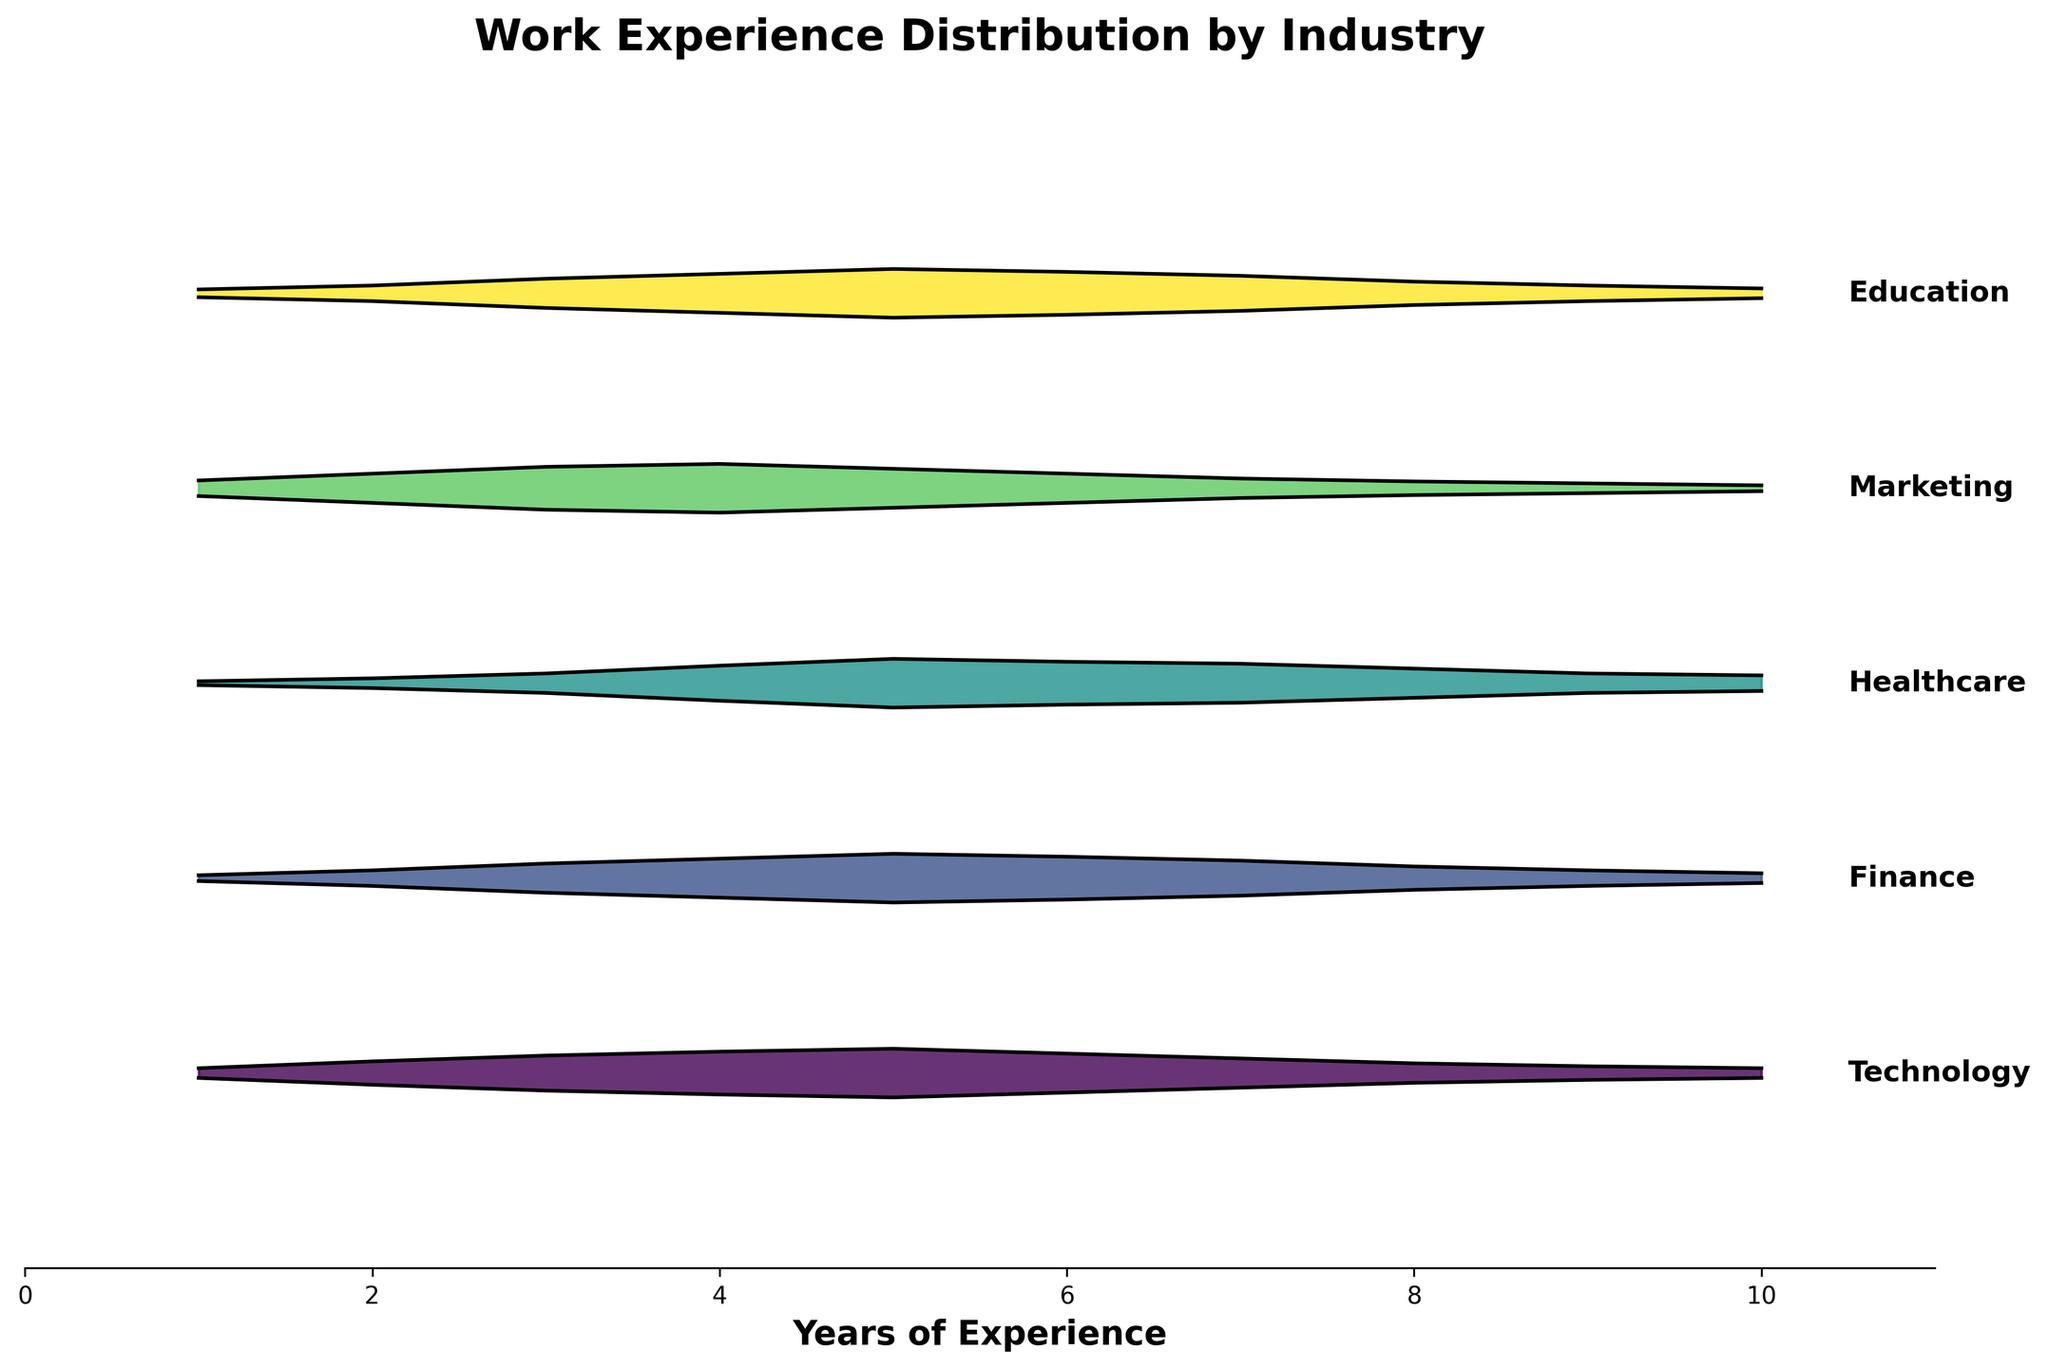What is the title of the plot? The title of the plot is usually located at the top of the figure. It gives an overview of what the plot is about. From the provided data, it says "Work Experience Distribution by Industry".
Answer: Work Experience Distribution by Industry Which industry has the peak density at 5 years of experience? To find the peak density at 5 years, look at the highest point on the plot for each industry at the 5-year mark. This peak is 0.25 for Technology, Finance, Healthcare, Marketing, and Education.
Answer: Technology, Finance, Healthcare, Marketing, Education How many years of experience do the majority of successful candidates in Healthcare have? Look at the apex of the distribution curve for Healthcare. The highest density, or the peak, corresponds to the most common experience duration. For Healthcare, the peak is at 5 years of experience.
Answer: 5 years Compare the peak density of the Marketing industry with the Finance industry. Which one is higher? By examining the ridgeline curves, note the peak of each curve. For Marketing, the peak density at any experience level is 0.25 at 4 years, while the peak for Finance is also 0.25 at 5 years. Thus, both have the same peak density values.
Answer: Equal Which industry shows a relatively uniform distribution from 5 to 8 years of experience? A relatively uniform distribution would mean that there are no sharp peaks or valleys across the specified range. By observing the plot, Technology shows such a pattern from 5 to 7 years.
Answer: Technology What is the trend of experience density in Education after 7 years? After 7 years, observe how the density values decline in Education. The density at 7 years is 0.18, decreasing to 0.12 at 8 years, 0.08 at 9 years, and 0.05 at 10 years.
Answer: Decreasing Which industry has the least density at 1 year of experience? To find the industry with the least density at 1 year, compare the density values at the 1-year mark across all industries. Healthcare has the least density with 0.02.
Answer: Healthcare In the plot, which industry peaks at the highest experience level (10 years)? To determine this, observe where each industry's curves peak the last. Healthcare has a notable density at 10 years, though it's also important to compare others. However, none peak last as high as Education, which peaks at 10 years identically with other industries.
Answer: Healthy, Education Is the density distribution symmetric for any industry? Symmetric distributions have the same shape on either side of the peak. From examining the plot, the density distribution for Technology and Finance exhibit symmetric patterns around the peak at 5 years.
Answer: Technology and Finance 